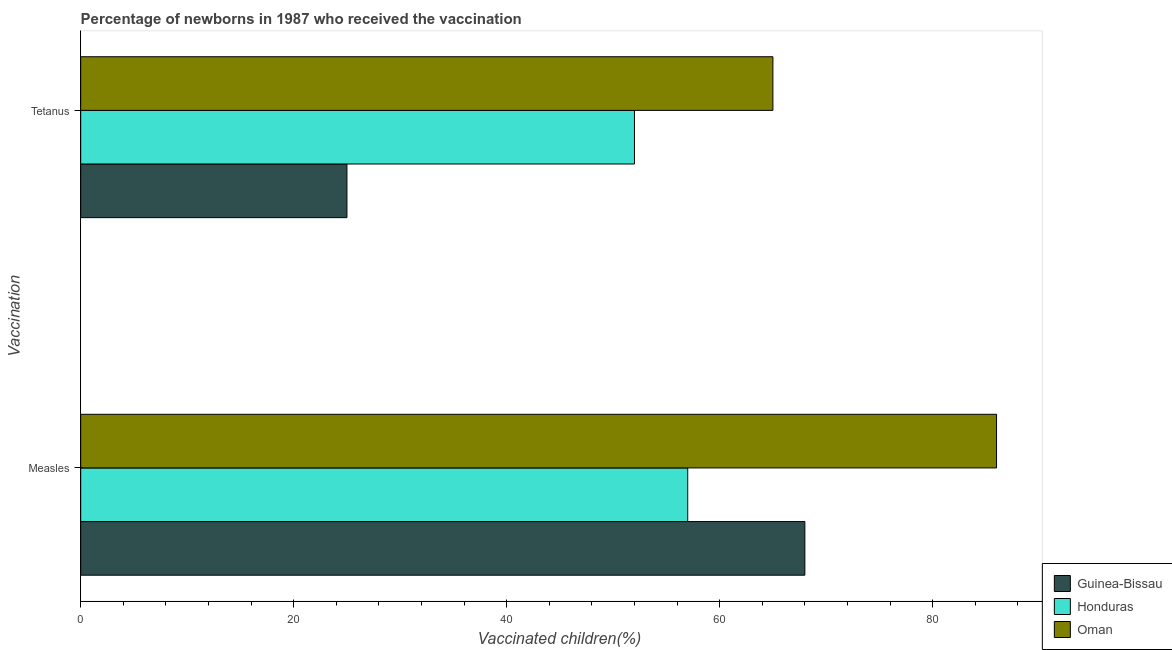How many different coloured bars are there?
Ensure brevity in your answer.  3. Are the number of bars per tick equal to the number of legend labels?
Your response must be concise. Yes. Are the number of bars on each tick of the Y-axis equal?
Ensure brevity in your answer.  Yes. How many bars are there on the 1st tick from the top?
Your response must be concise. 3. How many bars are there on the 2nd tick from the bottom?
Provide a short and direct response. 3. What is the label of the 2nd group of bars from the top?
Your answer should be compact. Measles. What is the percentage of newborns who received vaccination for tetanus in Oman?
Offer a very short reply. 65. Across all countries, what is the maximum percentage of newborns who received vaccination for measles?
Ensure brevity in your answer.  86. Across all countries, what is the minimum percentage of newborns who received vaccination for tetanus?
Offer a terse response. 25. In which country was the percentage of newborns who received vaccination for tetanus maximum?
Your answer should be compact. Oman. In which country was the percentage of newborns who received vaccination for measles minimum?
Keep it short and to the point. Honduras. What is the total percentage of newborns who received vaccination for measles in the graph?
Give a very brief answer. 211. What is the difference between the percentage of newborns who received vaccination for measles in Guinea-Bissau and that in Oman?
Provide a short and direct response. -18. What is the difference between the percentage of newborns who received vaccination for tetanus in Guinea-Bissau and the percentage of newborns who received vaccination for measles in Oman?
Provide a short and direct response. -61. What is the average percentage of newborns who received vaccination for measles per country?
Ensure brevity in your answer.  70.33. What is the difference between the percentage of newborns who received vaccination for tetanus and percentage of newborns who received vaccination for measles in Oman?
Offer a very short reply. -21. What is the ratio of the percentage of newborns who received vaccination for measles in Oman to that in Honduras?
Your response must be concise. 1.51. Is the percentage of newborns who received vaccination for measles in Honduras less than that in Oman?
Give a very brief answer. Yes. What does the 1st bar from the top in Tetanus represents?
Your answer should be very brief. Oman. What does the 1st bar from the bottom in Tetanus represents?
Provide a succinct answer. Guinea-Bissau. Are all the bars in the graph horizontal?
Offer a terse response. Yes. How many countries are there in the graph?
Give a very brief answer. 3. What is the difference between two consecutive major ticks on the X-axis?
Give a very brief answer. 20. How are the legend labels stacked?
Your answer should be compact. Vertical. What is the title of the graph?
Your answer should be very brief. Percentage of newborns in 1987 who received the vaccination. What is the label or title of the X-axis?
Make the answer very short. Vaccinated children(%)
. What is the label or title of the Y-axis?
Your answer should be compact. Vaccination. What is the Vaccinated children(%)
 of Guinea-Bissau in Measles?
Keep it short and to the point. 68. What is the Vaccinated children(%)
 in Honduras in Measles?
Offer a terse response. 57. What is the Vaccinated children(%)
 in Oman in Measles?
Provide a succinct answer. 86. What is the Vaccinated children(%)
 of Honduras in Tetanus?
Provide a short and direct response. 52. Across all Vaccination, what is the maximum Vaccinated children(%)
 of Guinea-Bissau?
Give a very brief answer. 68. Across all Vaccination, what is the maximum Vaccinated children(%)
 of Honduras?
Make the answer very short. 57. Across all Vaccination, what is the minimum Vaccinated children(%)
 in Honduras?
Provide a short and direct response. 52. What is the total Vaccinated children(%)
 of Guinea-Bissau in the graph?
Provide a succinct answer. 93. What is the total Vaccinated children(%)
 in Honduras in the graph?
Make the answer very short. 109. What is the total Vaccinated children(%)
 of Oman in the graph?
Your answer should be very brief. 151. What is the difference between the Vaccinated children(%)
 of Guinea-Bissau in Measles and that in Tetanus?
Your answer should be compact. 43. What is the difference between the Vaccinated children(%)
 in Oman in Measles and that in Tetanus?
Give a very brief answer. 21. What is the difference between the Vaccinated children(%)
 of Guinea-Bissau in Measles and the Vaccinated children(%)
 of Oman in Tetanus?
Keep it short and to the point. 3. What is the difference between the Vaccinated children(%)
 of Honduras in Measles and the Vaccinated children(%)
 of Oman in Tetanus?
Offer a very short reply. -8. What is the average Vaccinated children(%)
 of Guinea-Bissau per Vaccination?
Ensure brevity in your answer.  46.5. What is the average Vaccinated children(%)
 of Honduras per Vaccination?
Make the answer very short. 54.5. What is the average Vaccinated children(%)
 of Oman per Vaccination?
Provide a short and direct response. 75.5. What is the difference between the Vaccinated children(%)
 of Guinea-Bissau and Vaccinated children(%)
 of Oman in Measles?
Your answer should be compact. -18. What is the difference between the Vaccinated children(%)
 in Honduras and Vaccinated children(%)
 in Oman in Measles?
Make the answer very short. -29. What is the ratio of the Vaccinated children(%)
 in Guinea-Bissau in Measles to that in Tetanus?
Your answer should be very brief. 2.72. What is the ratio of the Vaccinated children(%)
 in Honduras in Measles to that in Tetanus?
Make the answer very short. 1.1. What is the ratio of the Vaccinated children(%)
 of Oman in Measles to that in Tetanus?
Provide a short and direct response. 1.32. What is the difference between the highest and the second highest Vaccinated children(%)
 in Oman?
Provide a succinct answer. 21. What is the difference between the highest and the lowest Vaccinated children(%)
 in Honduras?
Offer a terse response. 5. 